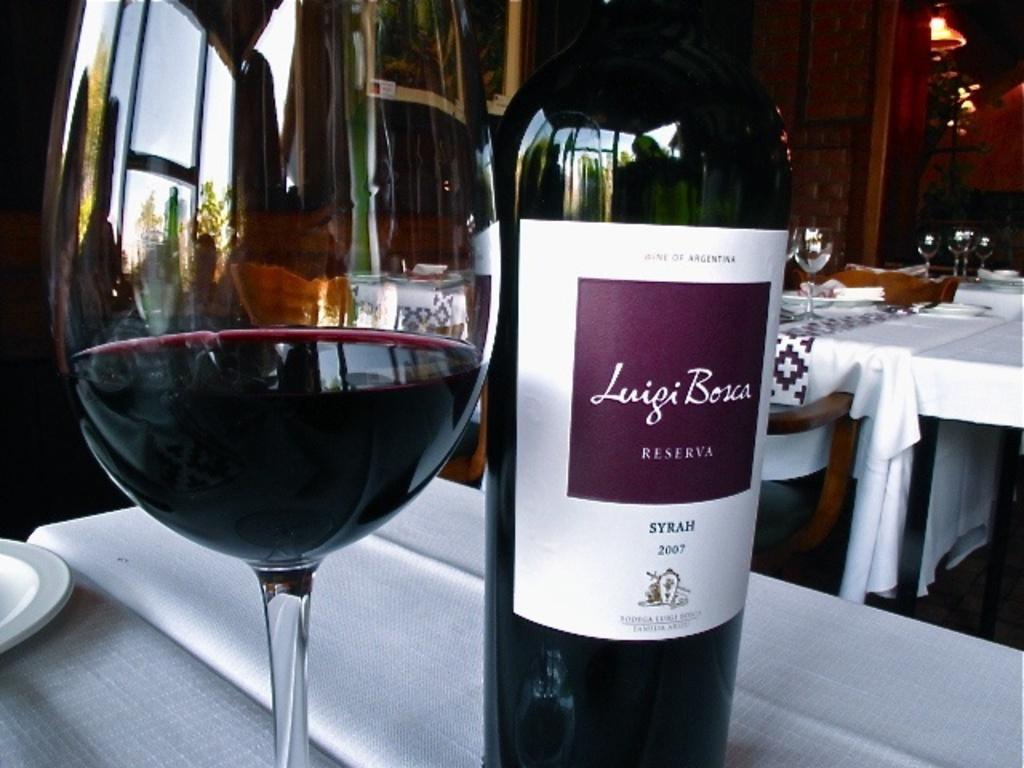Provide a one-sentence caption for the provided image. A wine glass sitting next to a bottle of Luigi Bosca Reserva 2007 wine. 